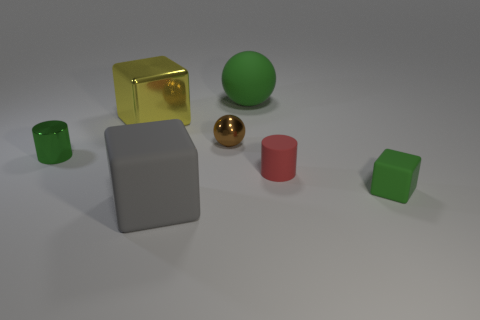Do the green object on the left side of the large gray block and the green rubber thing that is in front of the brown ball have the same size? Yes, the green objects—one on the left side of the large gray block and the other green rubber item in front of the brown ball—appear to be the same size. They both seem to be small, roughly cubical elements that likely function as some kind of simple geometric shape reference in this collection of objects. 